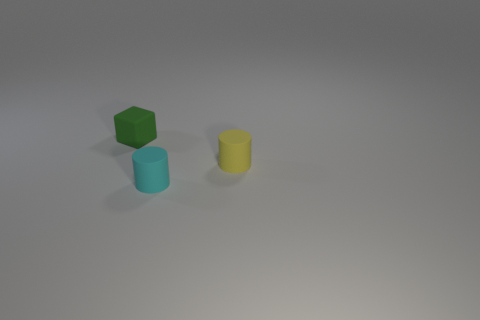Are there fewer small cylinders that are on the left side of the yellow thing than cyan matte objects in front of the cyan object?
Offer a terse response. No. What number of other small green things have the same material as the green thing?
Your response must be concise. 0. Is there a small yellow cylinder right of the rubber thing that is behind the thing to the right of the tiny cyan cylinder?
Give a very brief answer. Yes. What number of blocks are tiny green rubber objects or small yellow things?
Provide a short and direct response. 1. Do the small cyan rubber object and the tiny matte object that is to the left of the cyan rubber thing have the same shape?
Make the answer very short. No. Are there fewer cubes to the right of the yellow object than cubes?
Ensure brevity in your answer.  Yes. Are there any tiny green things in front of the tiny yellow matte thing?
Your response must be concise. No. Is there a gray matte thing of the same shape as the tiny green rubber object?
Your response must be concise. No. There is a cyan rubber thing that is the same size as the matte block; what is its shape?
Your answer should be compact. Cylinder. What number of objects are rubber objects that are in front of the cube or purple metal cubes?
Give a very brief answer. 2. 